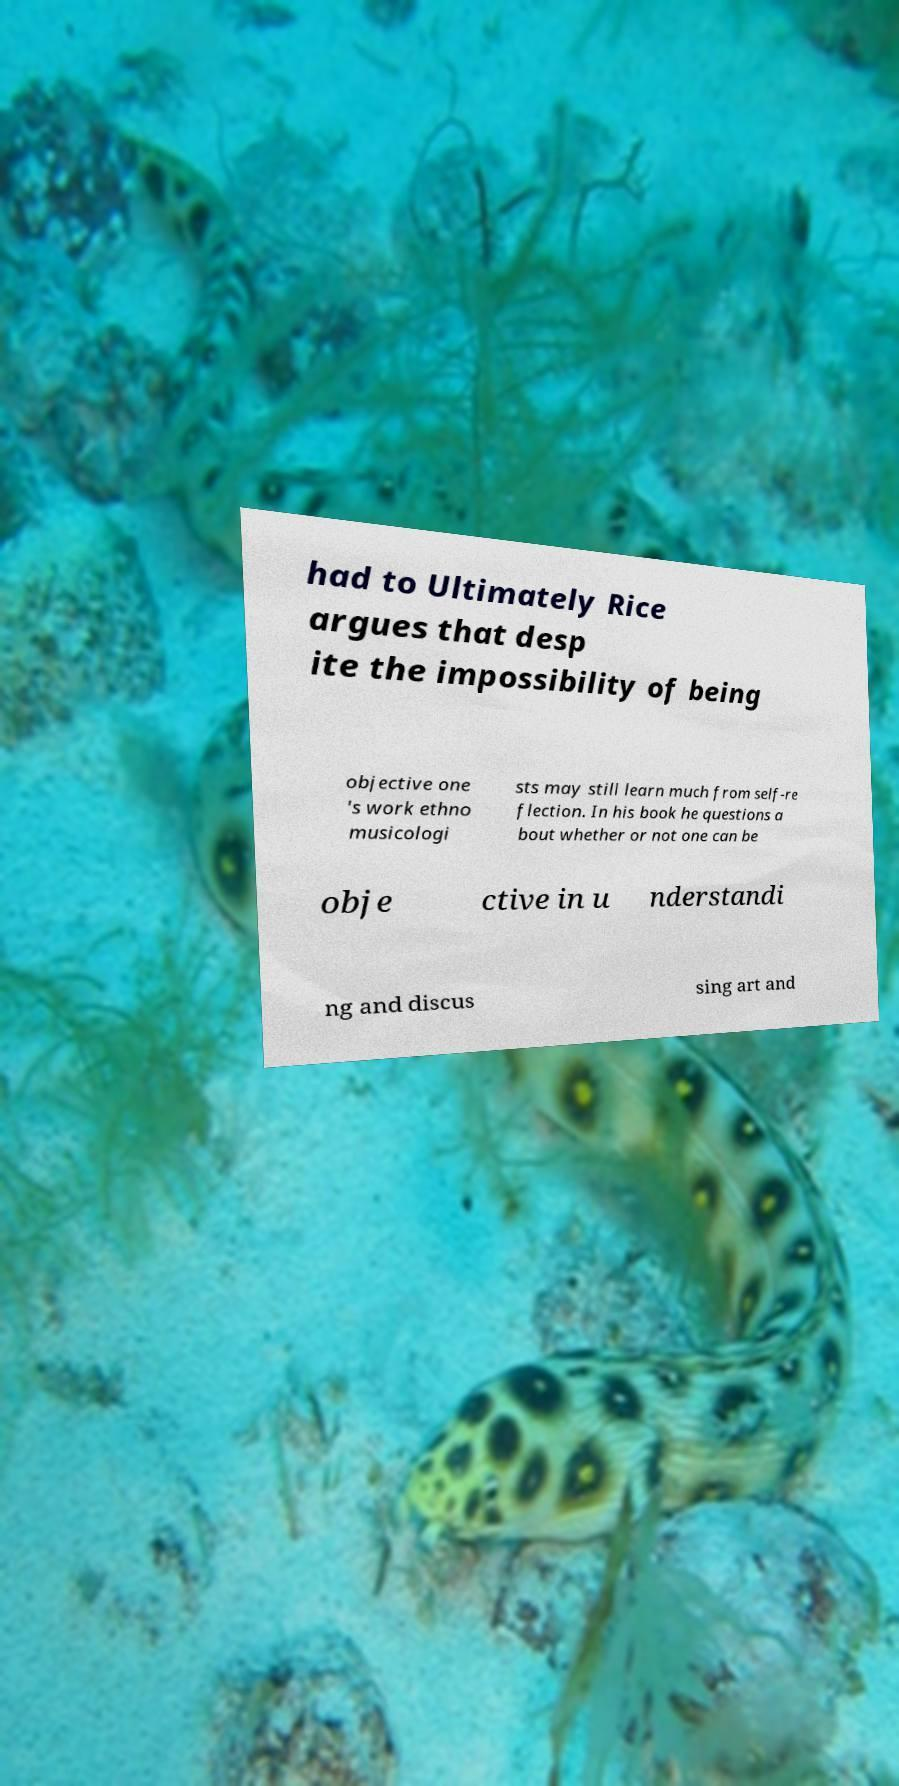Please read and relay the text visible in this image. What does it say? had to Ultimately Rice argues that desp ite the impossibility of being objective one 's work ethno musicologi sts may still learn much from self-re flection. In his book he questions a bout whether or not one can be obje ctive in u nderstandi ng and discus sing art and 